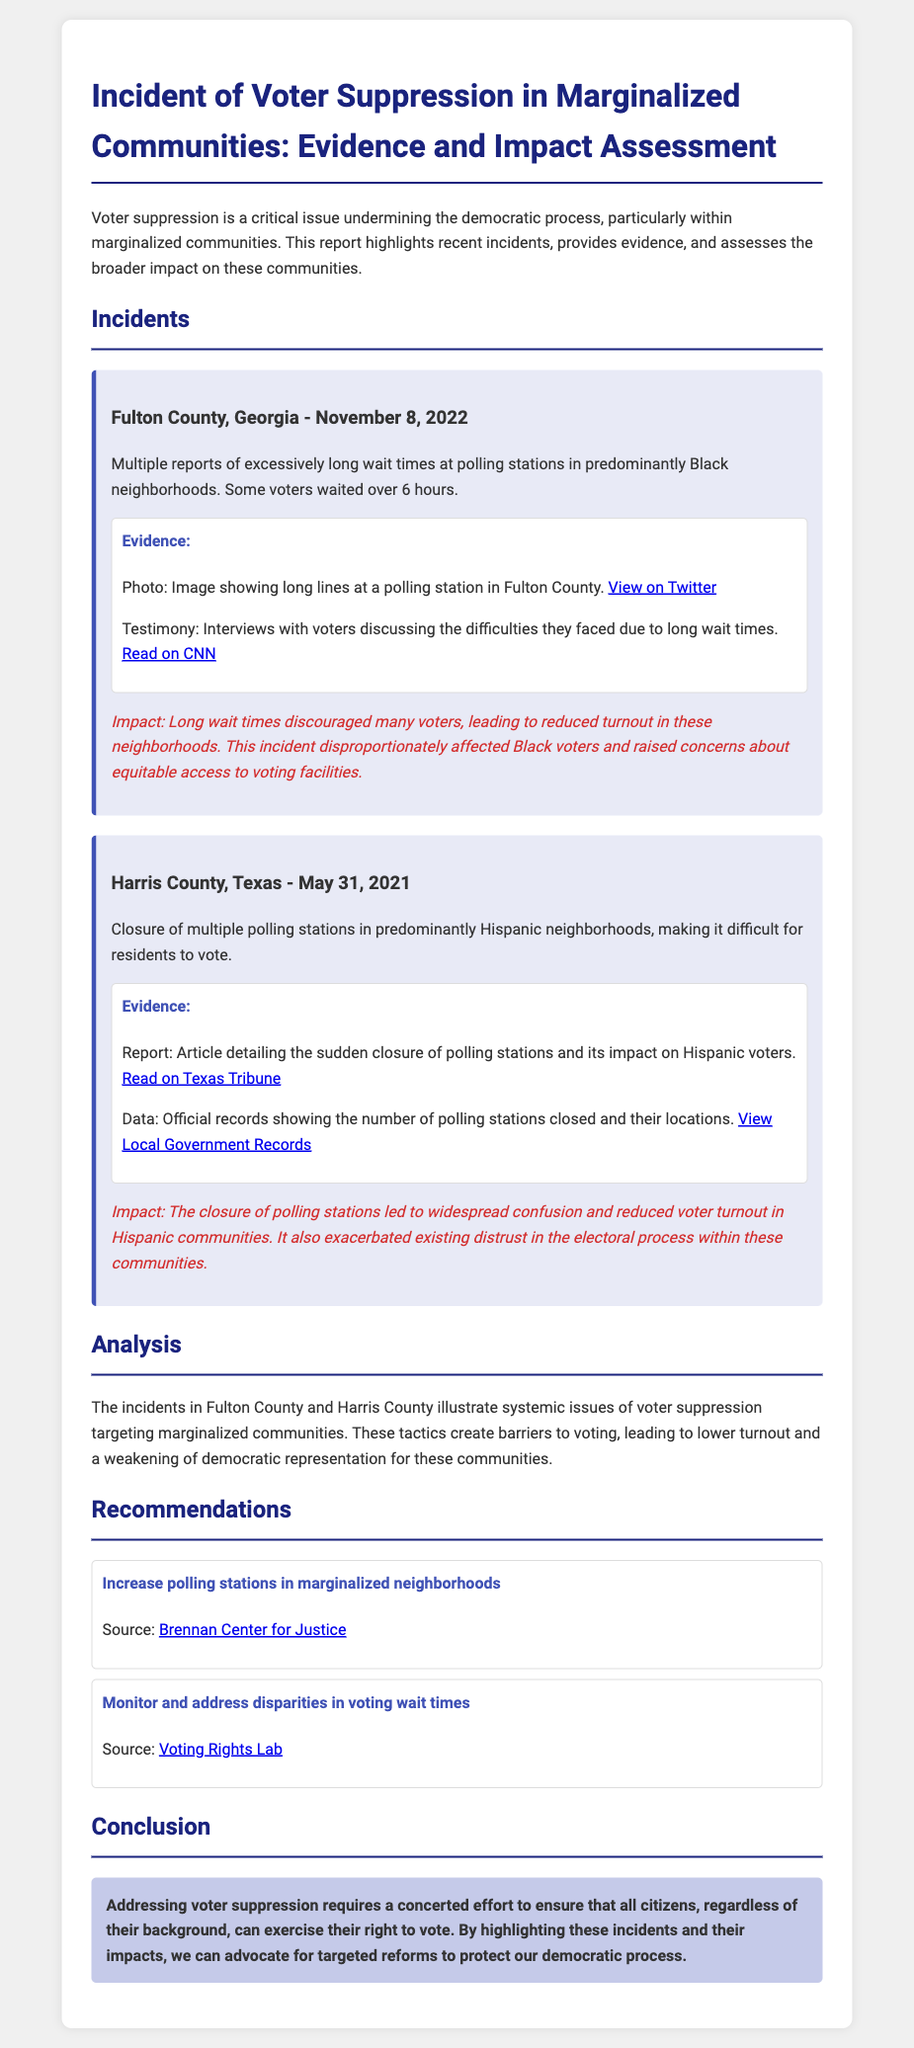what is the location of the first incident? The first incident occurred in Fulton County, Georgia.
Answer: Fulton County, Georgia what was the date of the incident in Harris County? The incident in Harris County occurred on May 31, 2021.
Answer: May 31, 2021 how long did some voters wait in Fulton County? Some voters waited over 6 hours in Fulton County.
Answer: over 6 hours what was the impact of long wait times in Fulton County? Long wait times discouraged many voters, leading to reduced turnout.
Answer: reduced turnout what was a primary reason for voter suppression in Harris County? The closure of multiple polling stations in predominantly Hispanic neighborhoods.
Answer: closure of multiple polling stations which community was primarily affected by the incident in Fulton County? The incident in Fulton County primarily affected Black voters.
Answer: Black voters what do the recommendations aim to improve? The recommendations aim to improve access to polling stations in marginalized neighborhoods.
Answer: access to polling stations which organization is referenced for recommendations on increasing polling stations? The Brennan Center for Justice is referenced for recommendations.
Answer: Brennan Center for Justice what is the overarching theme of the report? The overarching theme of the report is addressing voter suppression in marginalized communities.
Answer: addressing voter suppression 